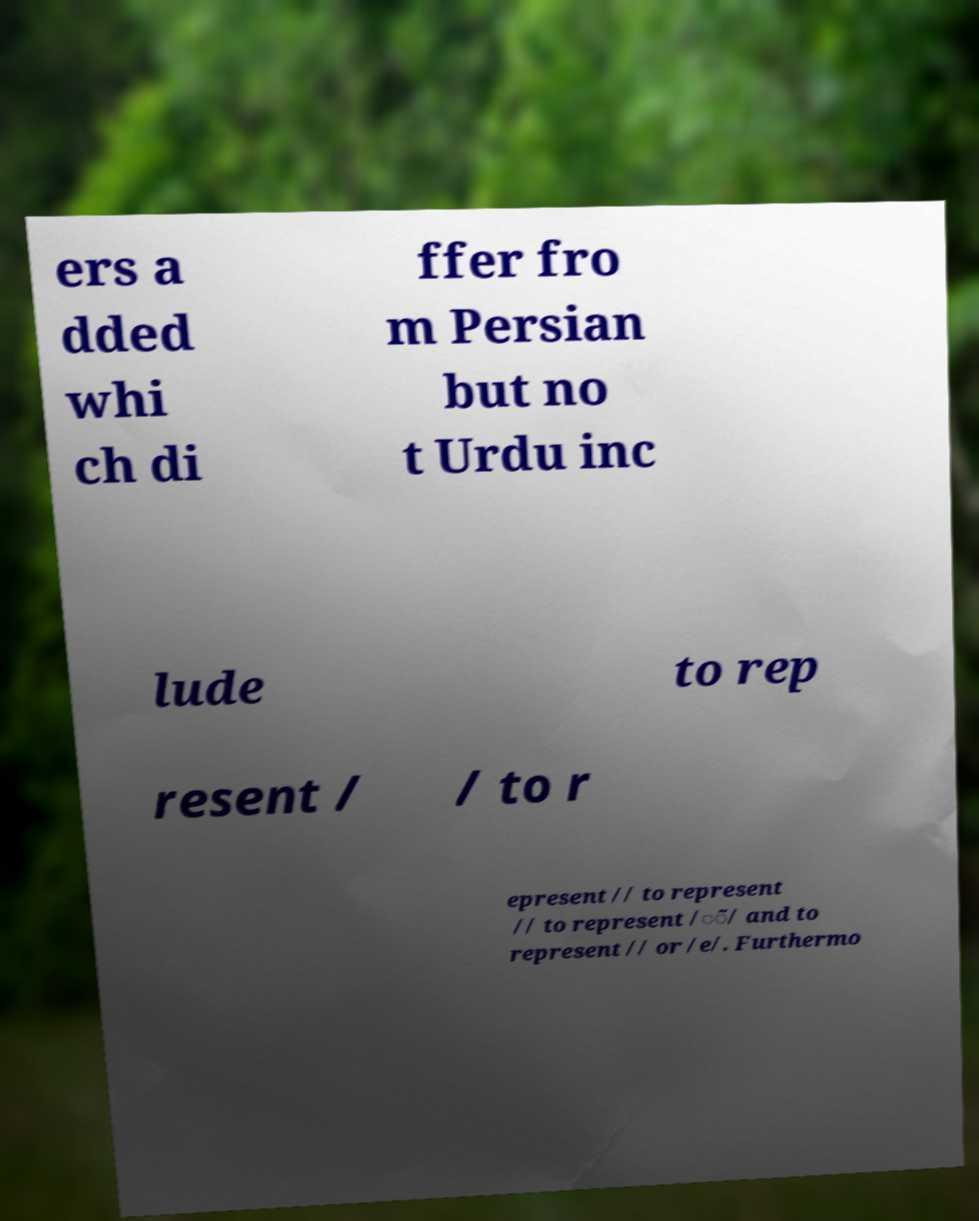Could you extract and type out the text from this image? ers a dded whi ch di ffer fro m Persian but no t Urdu inc lude to rep resent / / to r epresent // to represent // to represent /◌̃/ and to represent // or /e/. Furthermo 